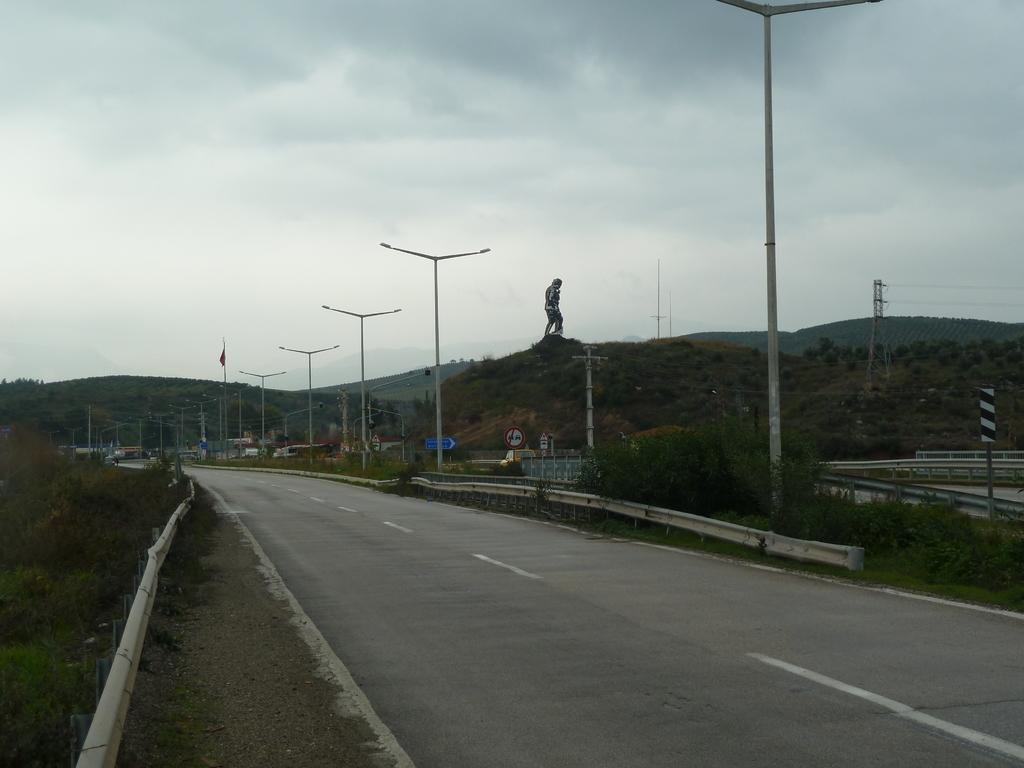What type of pathway can be seen in the image? There is a road in the image. What structures are present alongside the road? Street poles and street lights are visible in the image. What type of signs can be seen in the image? Sign boards and information boards are present in the image. What natural features are visible in the image? Hills, trees, plants, and the sky are visible in the image. What man-made object is present in the image? There is a statue in the image. What is flying in the sky in the image? Clouds are present in the sky. What type of angle is the rock forming in the image? There is no rock present in the image. What type of oatmeal is being served in the image? There is no oatmeal present in the image. 